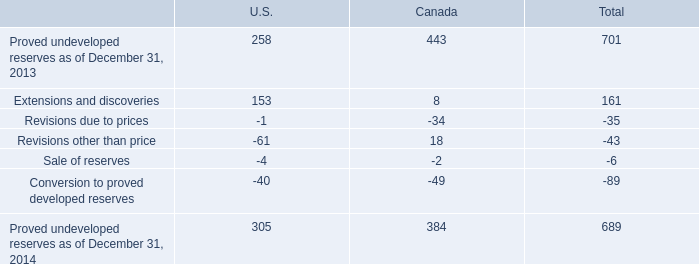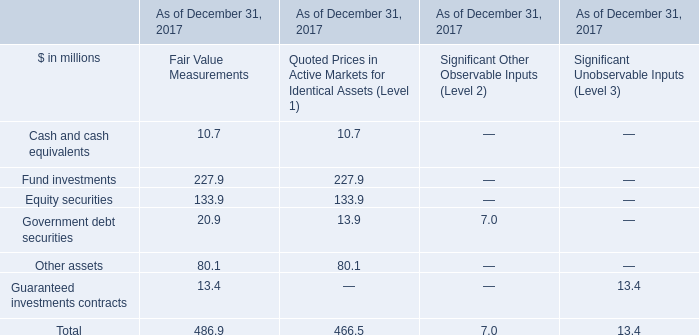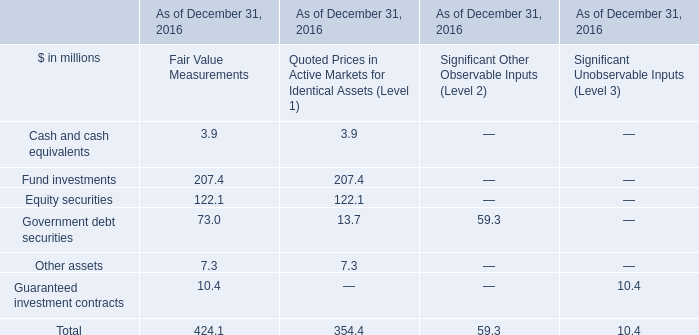what percentage of total proved undeveloped resources as of dec 31 , 2014 does extensions and discoveries and proved undeveloped resources as of dec 31 , 2013 account for? 
Computations: (((701 + 161) / 689) * 100)
Answer: 125.10885. 